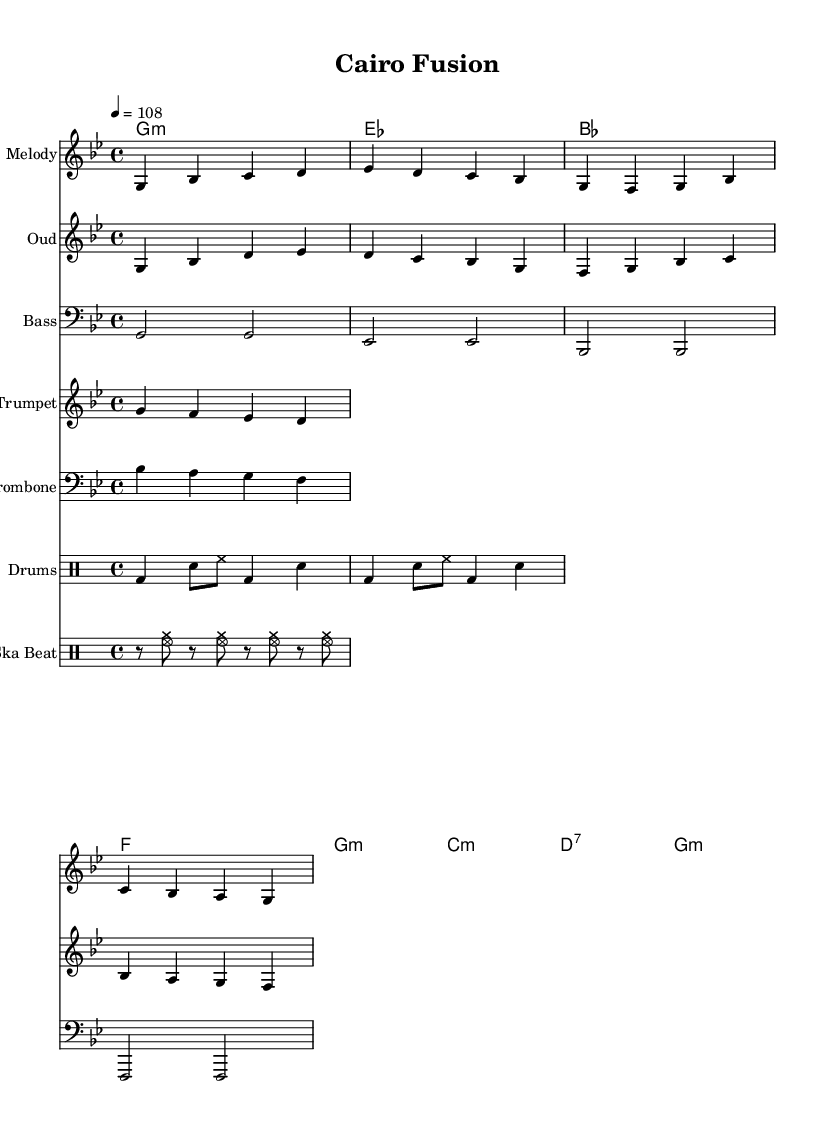What is the key signature of this music? The key signature is G minor, as indicated by the key signature symbol that appears at the beginning of the staff. G minor has two flats (B flat and E flat).
Answer: G minor What is the time signature of this piece? The time signature is 4/4, shown at the beginning of the score. This means there are four beats in each measure and a quarter note gets one beat.
Answer: 4/4 What is the tempo marking for the piece? The tempo is marked as 4 = 108, suggesting a pace of 108 beats per minute. This is typically indicated alongside the time signature.
Answer: 108 How many measures are in the melody part? By counting the measures represented in the melody staff, there are 8 measures in total. Each vertical line indicates the end of a measure.
Answer: 8 What instruments are featured in this score? The score features the Oud, Bass, Trumpet, Trombone, Drums, and a separate Ska Beat section. Each instrument is labeled at the beginning of its respective staff.
Answer: Oud, Bass, Trumpet, Trombone, Drums, Ska Beat What lyrics are associated with the melody? The lyrics provided are "Cairo streets alive with sound, Ancient and modern intertwined," placed below the melody notes indicating the vocal part that complements the instrumental music.
Answer: Cairo streets alive with sound, Ancient and modern intertwined What rhythmic feature is characteristic of ska music in this score? The rhythmic feature characteristic of ska music is the skank rhythm, which can be seen in the separate section labeled "Ska Beat" in the drum parts. It emphasizes the offbeat.
Answer: Offbeat emphasis 